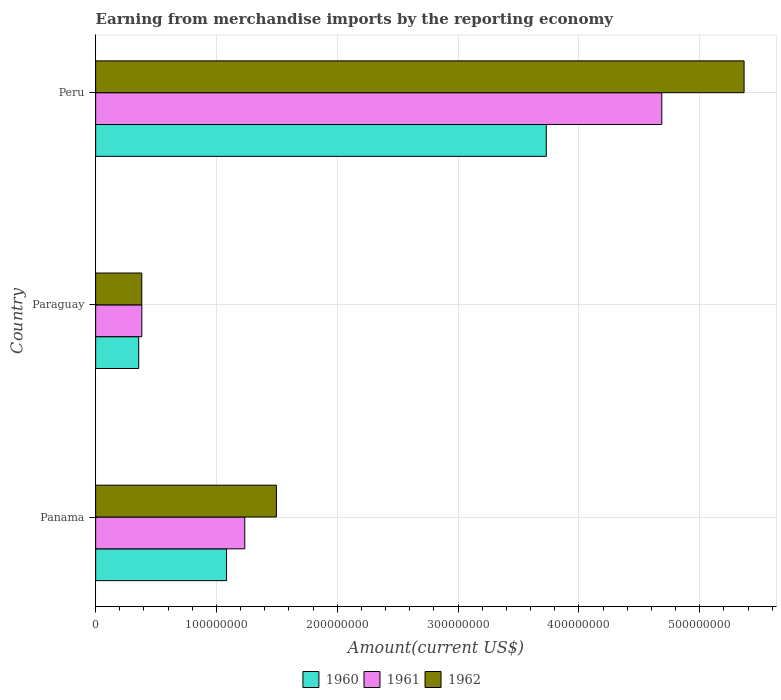How many groups of bars are there?
Provide a short and direct response. 3. Are the number of bars per tick equal to the number of legend labels?
Offer a terse response. Yes. Are the number of bars on each tick of the Y-axis equal?
Provide a short and direct response. Yes. How many bars are there on the 2nd tick from the top?
Your answer should be very brief. 3. How many bars are there on the 2nd tick from the bottom?
Your answer should be compact. 3. What is the label of the 1st group of bars from the top?
Your answer should be compact. Peru. In how many cases, is the number of bars for a given country not equal to the number of legend labels?
Provide a short and direct response. 0. What is the amount earned from merchandise imports in 1962 in Paraguay?
Make the answer very short. 3.82e+07. Across all countries, what is the maximum amount earned from merchandise imports in 1961?
Provide a short and direct response. 4.69e+08. Across all countries, what is the minimum amount earned from merchandise imports in 1961?
Provide a short and direct response. 3.82e+07. In which country was the amount earned from merchandise imports in 1961 minimum?
Your response must be concise. Paraguay. What is the total amount earned from merchandise imports in 1962 in the graph?
Your answer should be very brief. 7.24e+08. What is the difference between the amount earned from merchandise imports in 1961 in Panama and that in Paraguay?
Give a very brief answer. 8.52e+07. What is the difference between the amount earned from merchandise imports in 1961 in Peru and the amount earned from merchandise imports in 1960 in Panama?
Offer a terse response. 3.60e+08. What is the average amount earned from merchandise imports in 1962 per country?
Make the answer very short. 2.41e+08. What is the difference between the amount earned from merchandise imports in 1960 and amount earned from merchandise imports in 1961 in Paraguay?
Your answer should be compact. -2.59e+06. What is the ratio of the amount earned from merchandise imports in 1961 in Panama to that in Paraguay?
Provide a succinct answer. 3.23. Is the amount earned from merchandise imports in 1961 in Paraguay less than that in Peru?
Provide a short and direct response. Yes. What is the difference between the highest and the second highest amount earned from merchandise imports in 1960?
Your answer should be compact. 2.65e+08. What is the difference between the highest and the lowest amount earned from merchandise imports in 1960?
Your response must be concise. 3.37e+08. In how many countries, is the amount earned from merchandise imports in 1961 greater than the average amount earned from merchandise imports in 1961 taken over all countries?
Keep it short and to the point. 1. Is the sum of the amount earned from merchandise imports in 1961 in Panama and Peru greater than the maximum amount earned from merchandise imports in 1962 across all countries?
Provide a short and direct response. Yes. What does the 1st bar from the top in Panama represents?
Offer a terse response. 1962. How many bars are there?
Provide a succinct answer. 9. How many countries are there in the graph?
Ensure brevity in your answer.  3. Does the graph contain any zero values?
Offer a very short reply. No. Does the graph contain grids?
Provide a succinct answer. Yes. Where does the legend appear in the graph?
Keep it short and to the point. Bottom center. How many legend labels are there?
Give a very brief answer. 3. What is the title of the graph?
Offer a very short reply. Earning from merchandise imports by the reporting economy. Does "1999" appear as one of the legend labels in the graph?
Make the answer very short. No. What is the label or title of the X-axis?
Make the answer very short. Amount(current US$). What is the label or title of the Y-axis?
Offer a terse response. Country. What is the Amount(current US$) of 1960 in Panama?
Make the answer very short. 1.08e+08. What is the Amount(current US$) in 1961 in Panama?
Provide a short and direct response. 1.23e+08. What is the Amount(current US$) of 1962 in Panama?
Provide a succinct answer. 1.50e+08. What is the Amount(current US$) in 1960 in Paraguay?
Keep it short and to the point. 3.56e+07. What is the Amount(current US$) of 1961 in Paraguay?
Keep it short and to the point. 3.82e+07. What is the Amount(current US$) in 1962 in Paraguay?
Give a very brief answer. 3.82e+07. What is the Amount(current US$) of 1960 in Peru?
Give a very brief answer. 3.73e+08. What is the Amount(current US$) of 1961 in Peru?
Provide a short and direct response. 4.69e+08. What is the Amount(current US$) in 1962 in Peru?
Keep it short and to the point. 5.37e+08. Across all countries, what is the maximum Amount(current US$) of 1960?
Your response must be concise. 3.73e+08. Across all countries, what is the maximum Amount(current US$) in 1961?
Your response must be concise. 4.69e+08. Across all countries, what is the maximum Amount(current US$) in 1962?
Provide a succinct answer. 5.37e+08. Across all countries, what is the minimum Amount(current US$) in 1960?
Give a very brief answer. 3.56e+07. Across all countries, what is the minimum Amount(current US$) of 1961?
Provide a short and direct response. 3.82e+07. Across all countries, what is the minimum Amount(current US$) of 1962?
Your answer should be very brief. 3.82e+07. What is the total Amount(current US$) of 1960 in the graph?
Offer a terse response. 5.17e+08. What is the total Amount(current US$) of 1961 in the graph?
Keep it short and to the point. 6.30e+08. What is the total Amount(current US$) in 1962 in the graph?
Keep it short and to the point. 7.24e+08. What is the difference between the Amount(current US$) in 1960 in Panama and that in Paraguay?
Offer a terse response. 7.27e+07. What is the difference between the Amount(current US$) of 1961 in Panama and that in Paraguay?
Your answer should be very brief. 8.52e+07. What is the difference between the Amount(current US$) in 1962 in Panama and that in Paraguay?
Keep it short and to the point. 1.11e+08. What is the difference between the Amount(current US$) in 1960 in Panama and that in Peru?
Your response must be concise. -2.65e+08. What is the difference between the Amount(current US$) in 1961 in Panama and that in Peru?
Keep it short and to the point. -3.45e+08. What is the difference between the Amount(current US$) in 1962 in Panama and that in Peru?
Keep it short and to the point. -3.87e+08. What is the difference between the Amount(current US$) of 1960 in Paraguay and that in Peru?
Keep it short and to the point. -3.37e+08. What is the difference between the Amount(current US$) in 1961 in Paraguay and that in Peru?
Your response must be concise. -4.30e+08. What is the difference between the Amount(current US$) of 1962 in Paraguay and that in Peru?
Your answer should be compact. -4.99e+08. What is the difference between the Amount(current US$) in 1960 in Panama and the Amount(current US$) in 1961 in Paraguay?
Offer a very short reply. 7.01e+07. What is the difference between the Amount(current US$) of 1960 in Panama and the Amount(current US$) of 1962 in Paraguay?
Your answer should be compact. 7.02e+07. What is the difference between the Amount(current US$) of 1961 in Panama and the Amount(current US$) of 1962 in Paraguay?
Keep it short and to the point. 8.52e+07. What is the difference between the Amount(current US$) in 1960 in Panama and the Amount(current US$) in 1961 in Peru?
Your response must be concise. -3.60e+08. What is the difference between the Amount(current US$) in 1960 in Panama and the Amount(current US$) in 1962 in Peru?
Provide a short and direct response. -4.28e+08. What is the difference between the Amount(current US$) of 1961 in Panama and the Amount(current US$) of 1962 in Peru?
Provide a short and direct response. -4.13e+08. What is the difference between the Amount(current US$) of 1960 in Paraguay and the Amount(current US$) of 1961 in Peru?
Make the answer very short. -4.33e+08. What is the difference between the Amount(current US$) in 1960 in Paraguay and the Amount(current US$) in 1962 in Peru?
Make the answer very short. -5.01e+08. What is the difference between the Amount(current US$) in 1961 in Paraguay and the Amount(current US$) in 1962 in Peru?
Provide a succinct answer. -4.98e+08. What is the average Amount(current US$) in 1960 per country?
Give a very brief answer. 1.72e+08. What is the average Amount(current US$) in 1961 per country?
Ensure brevity in your answer.  2.10e+08. What is the average Amount(current US$) of 1962 per country?
Your answer should be compact. 2.41e+08. What is the difference between the Amount(current US$) of 1960 and Amount(current US$) of 1961 in Panama?
Provide a succinct answer. -1.51e+07. What is the difference between the Amount(current US$) in 1960 and Amount(current US$) in 1962 in Panama?
Your response must be concise. -4.12e+07. What is the difference between the Amount(current US$) of 1961 and Amount(current US$) of 1962 in Panama?
Provide a short and direct response. -2.62e+07. What is the difference between the Amount(current US$) in 1960 and Amount(current US$) in 1961 in Paraguay?
Keep it short and to the point. -2.59e+06. What is the difference between the Amount(current US$) of 1960 and Amount(current US$) of 1962 in Paraguay?
Keep it short and to the point. -2.55e+06. What is the difference between the Amount(current US$) of 1961 and Amount(current US$) of 1962 in Paraguay?
Make the answer very short. 3.80e+04. What is the difference between the Amount(current US$) of 1960 and Amount(current US$) of 1961 in Peru?
Offer a very short reply. -9.56e+07. What is the difference between the Amount(current US$) in 1960 and Amount(current US$) in 1962 in Peru?
Your answer should be compact. -1.64e+08. What is the difference between the Amount(current US$) in 1961 and Amount(current US$) in 1962 in Peru?
Give a very brief answer. -6.81e+07. What is the ratio of the Amount(current US$) of 1960 in Panama to that in Paraguay?
Ensure brevity in your answer.  3.04. What is the ratio of the Amount(current US$) in 1961 in Panama to that in Paraguay?
Your answer should be very brief. 3.23. What is the ratio of the Amount(current US$) of 1962 in Panama to that in Paraguay?
Provide a succinct answer. 3.92. What is the ratio of the Amount(current US$) of 1960 in Panama to that in Peru?
Your response must be concise. 0.29. What is the ratio of the Amount(current US$) in 1961 in Panama to that in Peru?
Provide a succinct answer. 0.26. What is the ratio of the Amount(current US$) in 1962 in Panama to that in Peru?
Make the answer very short. 0.28. What is the ratio of the Amount(current US$) of 1960 in Paraguay to that in Peru?
Keep it short and to the point. 0.1. What is the ratio of the Amount(current US$) in 1961 in Paraguay to that in Peru?
Give a very brief answer. 0.08. What is the ratio of the Amount(current US$) in 1962 in Paraguay to that in Peru?
Your response must be concise. 0.07. What is the difference between the highest and the second highest Amount(current US$) of 1960?
Offer a very short reply. 2.65e+08. What is the difference between the highest and the second highest Amount(current US$) in 1961?
Give a very brief answer. 3.45e+08. What is the difference between the highest and the second highest Amount(current US$) of 1962?
Make the answer very short. 3.87e+08. What is the difference between the highest and the lowest Amount(current US$) in 1960?
Give a very brief answer. 3.37e+08. What is the difference between the highest and the lowest Amount(current US$) in 1961?
Your answer should be very brief. 4.30e+08. What is the difference between the highest and the lowest Amount(current US$) in 1962?
Provide a short and direct response. 4.99e+08. 